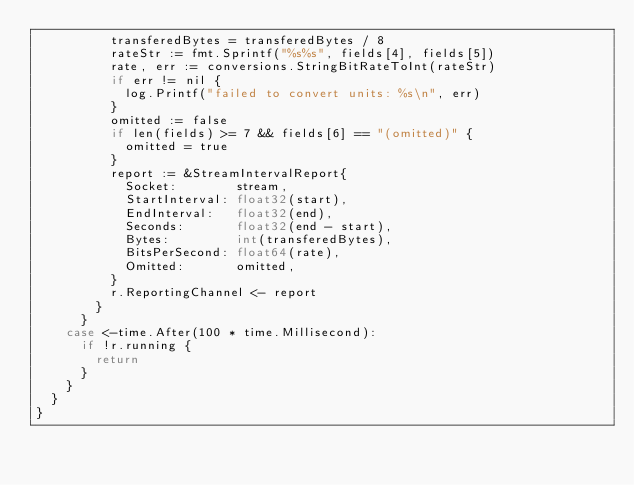<code> <loc_0><loc_0><loc_500><loc_500><_Go_>					transferedBytes = transferedBytes / 8
					rateStr := fmt.Sprintf("%s%s", fields[4], fields[5])
					rate, err := conversions.StringBitRateToInt(rateStr)
					if err != nil {
						log.Printf("failed to convert units: %s\n", err)
					}
					omitted := false
					if len(fields) >= 7 && fields[6] == "(omitted)" {
						omitted = true
					}
					report := &StreamIntervalReport{
						Socket:        stream,
						StartInterval: float32(start),
						EndInterval:   float32(end),
						Seconds:       float32(end - start),
						Bytes:         int(transferedBytes),
						BitsPerSecond: float64(rate),
						Omitted:       omitted,
					}
					r.ReportingChannel <- report
				}
			}
		case <-time.After(100 * time.Millisecond):
			if !r.running {
				return
			}
		}
	}
}
</code> 